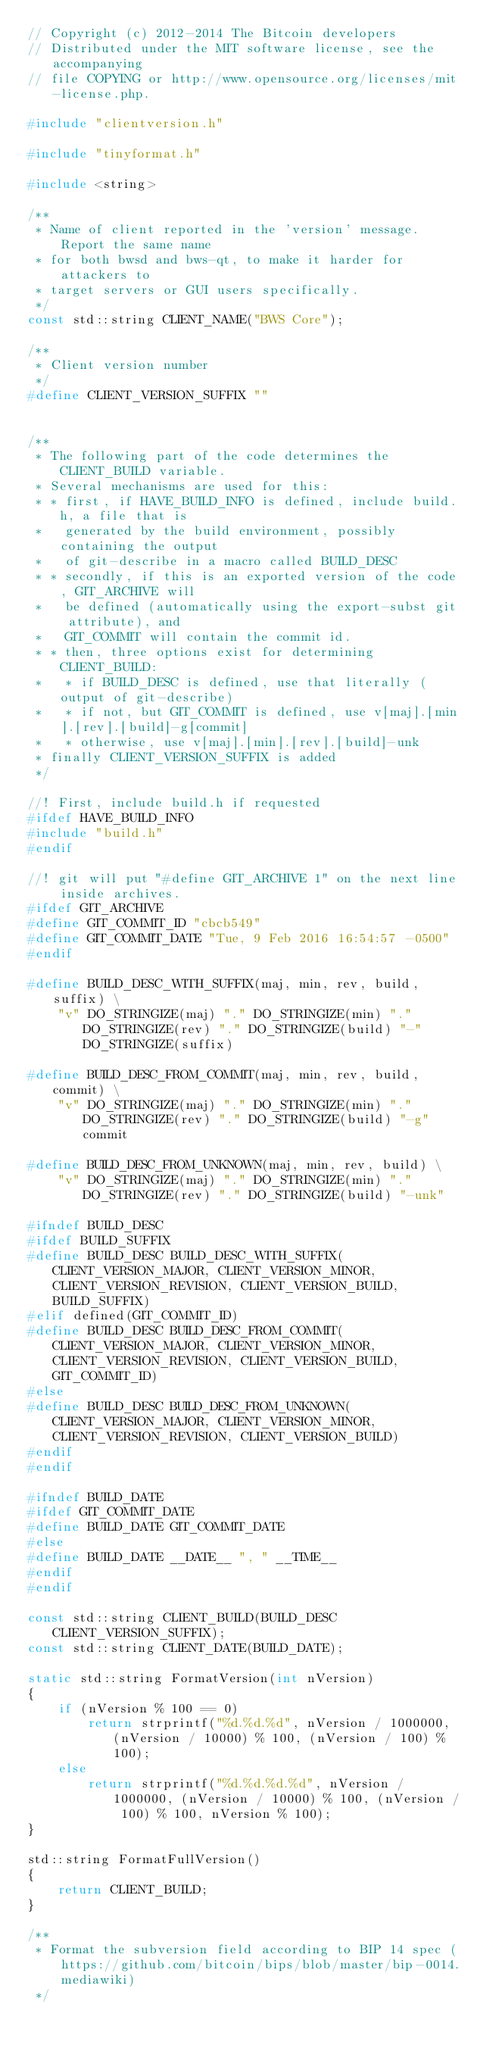<code> <loc_0><loc_0><loc_500><loc_500><_C++_>// Copyright (c) 2012-2014 The Bitcoin developers
// Distributed under the MIT software license, see the accompanying
// file COPYING or http://www.opensource.org/licenses/mit-license.php.

#include "clientversion.h"

#include "tinyformat.h"

#include <string>

/**
 * Name of client reported in the 'version' message. Report the same name
 * for both bwsd and bws-qt, to make it harder for attackers to
 * target servers or GUI users specifically.
 */
const std::string CLIENT_NAME("BWS Core");

/**
 * Client version number
 */
#define CLIENT_VERSION_SUFFIX ""


/**
 * The following part of the code determines the CLIENT_BUILD variable.
 * Several mechanisms are used for this:
 * * first, if HAVE_BUILD_INFO is defined, include build.h, a file that is
 *   generated by the build environment, possibly containing the output
 *   of git-describe in a macro called BUILD_DESC
 * * secondly, if this is an exported version of the code, GIT_ARCHIVE will
 *   be defined (automatically using the export-subst git attribute), and
 *   GIT_COMMIT will contain the commit id.
 * * then, three options exist for determining CLIENT_BUILD:
 *   * if BUILD_DESC is defined, use that literally (output of git-describe)
 *   * if not, but GIT_COMMIT is defined, use v[maj].[min].[rev].[build]-g[commit]
 *   * otherwise, use v[maj].[min].[rev].[build]-unk
 * finally CLIENT_VERSION_SUFFIX is added
 */

//! First, include build.h if requested
#ifdef HAVE_BUILD_INFO
#include "build.h"
#endif

//! git will put "#define GIT_ARCHIVE 1" on the next line inside archives.
#ifdef GIT_ARCHIVE
#define GIT_COMMIT_ID "cbcb549"
#define GIT_COMMIT_DATE "Tue, 9 Feb 2016 16:54:57 -0500"
#endif

#define BUILD_DESC_WITH_SUFFIX(maj, min, rev, build, suffix) \
    "v" DO_STRINGIZE(maj) "." DO_STRINGIZE(min) "." DO_STRINGIZE(rev) "." DO_STRINGIZE(build) "-" DO_STRINGIZE(suffix)

#define BUILD_DESC_FROM_COMMIT(maj, min, rev, build, commit) \
    "v" DO_STRINGIZE(maj) "." DO_STRINGIZE(min) "." DO_STRINGIZE(rev) "." DO_STRINGIZE(build) "-g" commit

#define BUILD_DESC_FROM_UNKNOWN(maj, min, rev, build) \
    "v" DO_STRINGIZE(maj) "." DO_STRINGIZE(min) "." DO_STRINGIZE(rev) "." DO_STRINGIZE(build) "-unk"

#ifndef BUILD_DESC
#ifdef BUILD_SUFFIX
#define BUILD_DESC BUILD_DESC_WITH_SUFFIX(CLIENT_VERSION_MAJOR, CLIENT_VERSION_MINOR, CLIENT_VERSION_REVISION, CLIENT_VERSION_BUILD, BUILD_SUFFIX)
#elif defined(GIT_COMMIT_ID)
#define BUILD_DESC BUILD_DESC_FROM_COMMIT(CLIENT_VERSION_MAJOR, CLIENT_VERSION_MINOR, CLIENT_VERSION_REVISION, CLIENT_VERSION_BUILD, GIT_COMMIT_ID)
#else
#define BUILD_DESC BUILD_DESC_FROM_UNKNOWN(CLIENT_VERSION_MAJOR, CLIENT_VERSION_MINOR, CLIENT_VERSION_REVISION, CLIENT_VERSION_BUILD)
#endif
#endif

#ifndef BUILD_DATE
#ifdef GIT_COMMIT_DATE
#define BUILD_DATE GIT_COMMIT_DATE
#else
#define BUILD_DATE __DATE__ ", " __TIME__
#endif
#endif

const std::string CLIENT_BUILD(BUILD_DESC CLIENT_VERSION_SUFFIX);
const std::string CLIENT_DATE(BUILD_DATE);

static std::string FormatVersion(int nVersion)
{
    if (nVersion % 100 == 0)
        return strprintf("%d.%d.%d", nVersion / 1000000, (nVersion / 10000) % 100, (nVersion / 100) % 100);
    else
        return strprintf("%d.%d.%d.%d", nVersion / 1000000, (nVersion / 10000) % 100, (nVersion / 100) % 100, nVersion % 100);
}

std::string FormatFullVersion()
{
    return CLIENT_BUILD;
}

/** 
 * Format the subversion field according to BIP 14 spec (https://github.com/bitcoin/bips/blob/master/bip-0014.mediawiki) 
 */</code> 